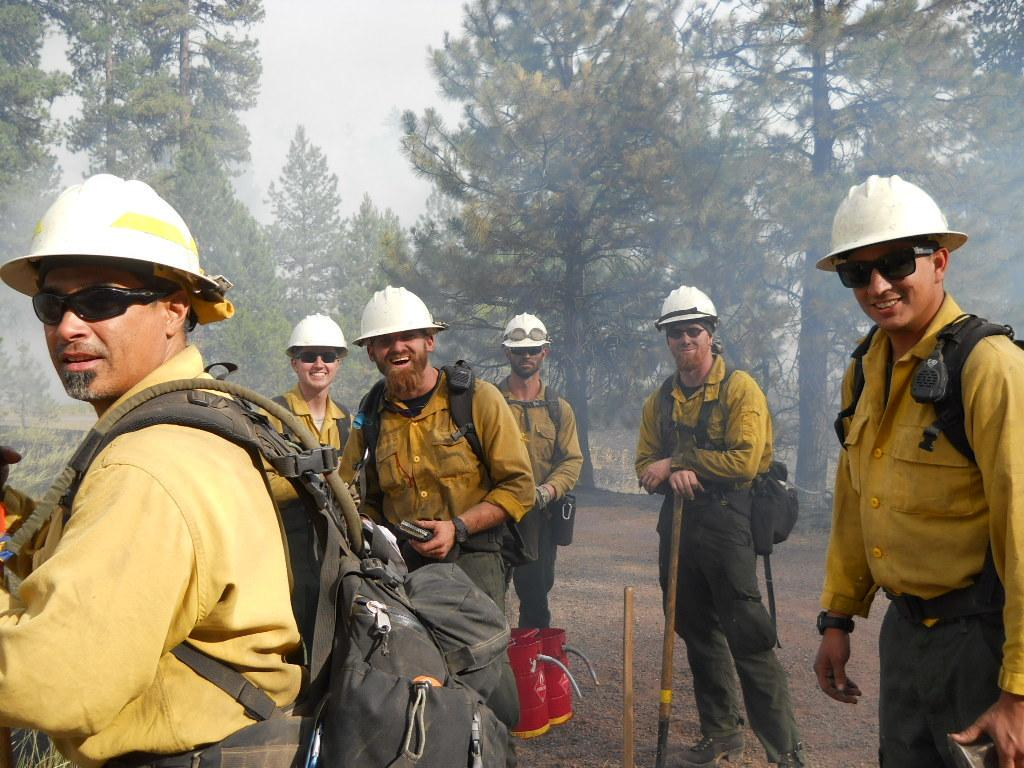Who or what is present in the image? There are people in the image. What are the people wearing? The people are wearing the same costume. What type of natural environment can be seen in the image? There are trees visible in the image. What part of the natural environment is visible in the image? The sky is visible in the image. What type of feather is being used for tax purposes in the image? There is no feather or tax-related activity present in the image. 